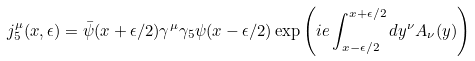<formula> <loc_0><loc_0><loc_500><loc_500>j _ { 5 } ^ { \mu } ( x , \epsilon ) = \bar { \psi } ( x + \epsilon / 2 ) \gamma ^ { \mu } \gamma _ { 5 } \psi ( x - \epsilon / 2 ) \exp \left ( i e \int _ { x - \epsilon / 2 } ^ { x + \epsilon / 2 } d y ^ { \nu } A _ { \nu } ( y ) \right )</formula> 